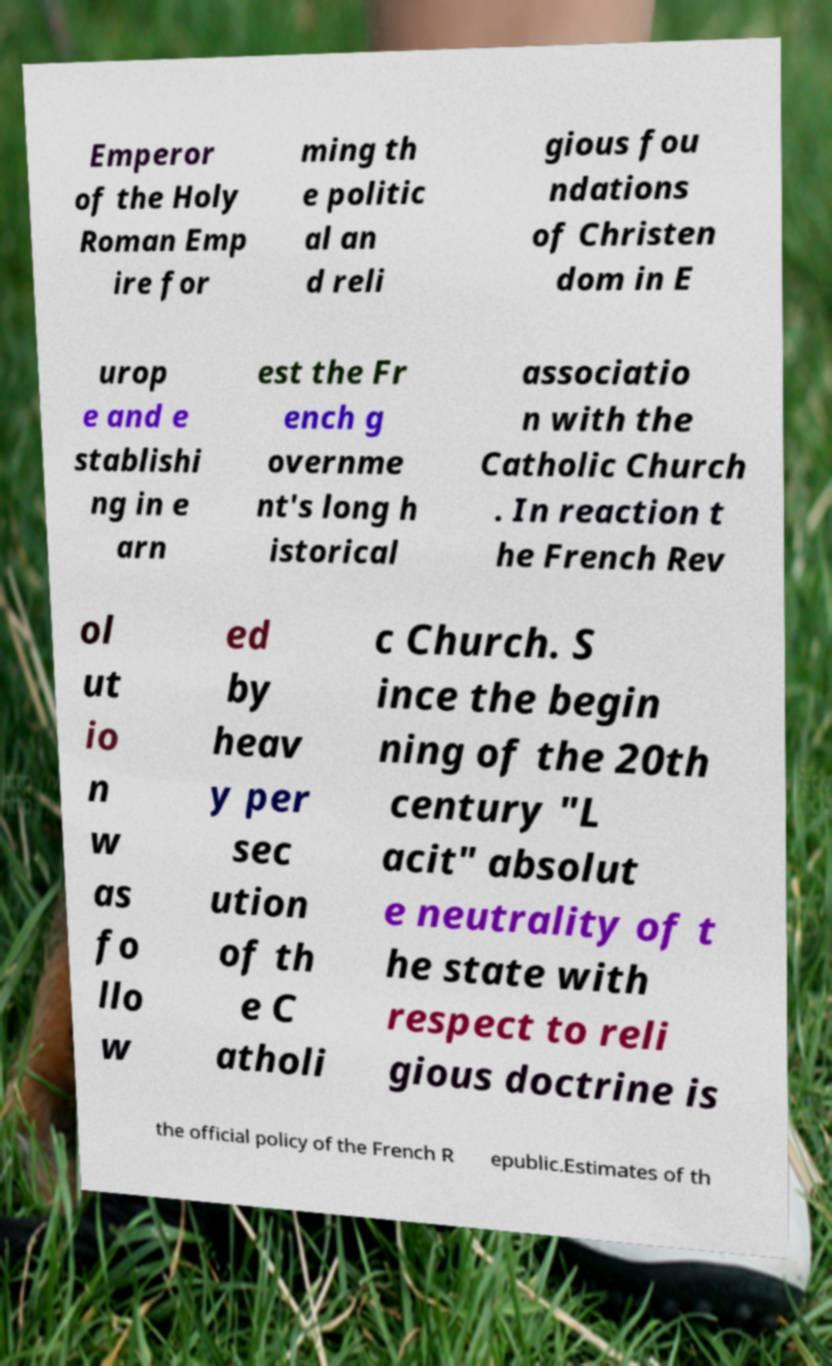Can you accurately transcribe the text from the provided image for me? Emperor of the Holy Roman Emp ire for ming th e politic al an d reli gious fou ndations of Christen dom in E urop e and e stablishi ng in e arn est the Fr ench g overnme nt's long h istorical associatio n with the Catholic Church . In reaction t he French Rev ol ut io n w as fo llo w ed by heav y per sec ution of th e C atholi c Church. S ince the begin ning of the 20th century "L acit" absolut e neutrality of t he state with respect to reli gious doctrine is the official policy of the French R epublic.Estimates of th 